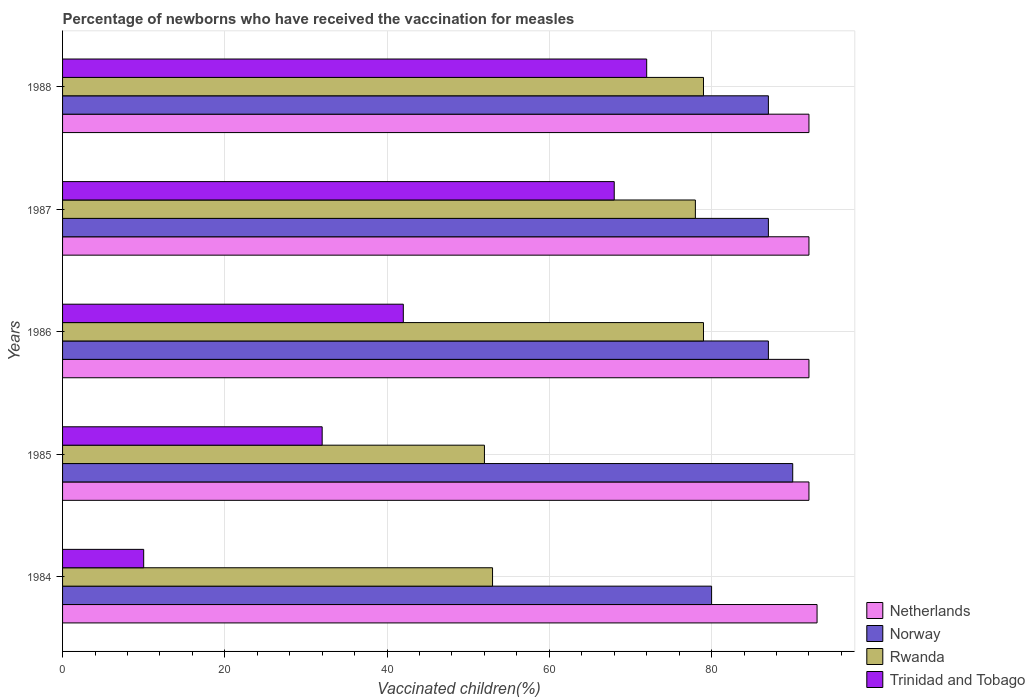Are the number of bars per tick equal to the number of legend labels?
Provide a succinct answer. Yes. Are the number of bars on each tick of the Y-axis equal?
Your response must be concise. Yes. How many bars are there on the 4th tick from the bottom?
Keep it short and to the point. 4. What is the label of the 3rd group of bars from the top?
Ensure brevity in your answer.  1986. What is the percentage of vaccinated children in Netherlands in 1984?
Ensure brevity in your answer.  93. Across all years, what is the maximum percentage of vaccinated children in Trinidad and Tobago?
Ensure brevity in your answer.  72. What is the total percentage of vaccinated children in Rwanda in the graph?
Ensure brevity in your answer.  341. What is the difference between the percentage of vaccinated children in Netherlands in 1987 and the percentage of vaccinated children in Trinidad and Tobago in 1984?
Keep it short and to the point. 82. What is the average percentage of vaccinated children in Rwanda per year?
Offer a terse response. 68.2. In the year 1986, what is the difference between the percentage of vaccinated children in Trinidad and Tobago and percentage of vaccinated children in Netherlands?
Provide a succinct answer. -50. In how many years, is the percentage of vaccinated children in Trinidad and Tobago greater than 72 %?
Your answer should be compact. 0. What is the ratio of the percentage of vaccinated children in Trinidad and Tobago in 1985 to that in 1987?
Make the answer very short. 0.47. Is the percentage of vaccinated children in Norway in 1986 less than that in 1987?
Provide a short and direct response. No. What is the difference between the highest and the second highest percentage of vaccinated children in Netherlands?
Offer a very short reply. 1. What is the difference between the highest and the lowest percentage of vaccinated children in Netherlands?
Your response must be concise. 1. Is the sum of the percentage of vaccinated children in Norway in 1984 and 1986 greater than the maximum percentage of vaccinated children in Rwanda across all years?
Keep it short and to the point. Yes. What does the 4th bar from the bottom in 1986 represents?
Provide a succinct answer. Trinidad and Tobago. Is it the case that in every year, the sum of the percentage of vaccinated children in Norway and percentage of vaccinated children in Rwanda is greater than the percentage of vaccinated children in Trinidad and Tobago?
Ensure brevity in your answer.  Yes. What is the difference between two consecutive major ticks on the X-axis?
Provide a short and direct response. 20. Are the values on the major ticks of X-axis written in scientific E-notation?
Offer a very short reply. No. Does the graph contain grids?
Provide a succinct answer. Yes. Where does the legend appear in the graph?
Provide a short and direct response. Bottom right. How many legend labels are there?
Offer a very short reply. 4. What is the title of the graph?
Make the answer very short. Percentage of newborns who have received the vaccination for measles. What is the label or title of the X-axis?
Provide a succinct answer. Vaccinated children(%). What is the label or title of the Y-axis?
Your answer should be compact. Years. What is the Vaccinated children(%) of Netherlands in 1984?
Give a very brief answer. 93. What is the Vaccinated children(%) of Rwanda in 1984?
Give a very brief answer. 53. What is the Vaccinated children(%) in Trinidad and Tobago in 1984?
Offer a very short reply. 10. What is the Vaccinated children(%) in Netherlands in 1985?
Your answer should be very brief. 92. What is the Vaccinated children(%) of Norway in 1985?
Offer a very short reply. 90. What is the Vaccinated children(%) of Netherlands in 1986?
Keep it short and to the point. 92. What is the Vaccinated children(%) in Norway in 1986?
Offer a very short reply. 87. What is the Vaccinated children(%) in Rwanda in 1986?
Keep it short and to the point. 79. What is the Vaccinated children(%) of Trinidad and Tobago in 1986?
Offer a terse response. 42. What is the Vaccinated children(%) in Netherlands in 1987?
Provide a short and direct response. 92. What is the Vaccinated children(%) in Norway in 1987?
Ensure brevity in your answer.  87. What is the Vaccinated children(%) in Netherlands in 1988?
Keep it short and to the point. 92. What is the Vaccinated children(%) of Norway in 1988?
Your answer should be compact. 87. What is the Vaccinated children(%) of Rwanda in 1988?
Offer a terse response. 79. What is the Vaccinated children(%) in Trinidad and Tobago in 1988?
Offer a very short reply. 72. Across all years, what is the maximum Vaccinated children(%) of Netherlands?
Ensure brevity in your answer.  93. Across all years, what is the maximum Vaccinated children(%) of Rwanda?
Ensure brevity in your answer.  79. Across all years, what is the maximum Vaccinated children(%) in Trinidad and Tobago?
Give a very brief answer. 72. Across all years, what is the minimum Vaccinated children(%) in Netherlands?
Provide a short and direct response. 92. Across all years, what is the minimum Vaccinated children(%) in Norway?
Provide a short and direct response. 80. Across all years, what is the minimum Vaccinated children(%) in Rwanda?
Make the answer very short. 52. Across all years, what is the minimum Vaccinated children(%) in Trinidad and Tobago?
Your response must be concise. 10. What is the total Vaccinated children(%) of Netherlands in the graph?
Make the answer very short. 461. What is the total Vaccinated children(%) of Norway in the graph?
Make the answer very short. 431. What is the total Vaccinated children(%) of Rwanda in the graph?
Your answer should be very brief. 341. What is the total Vaccinated children(%) of Trinidad and Tobago in the graph?
Make the answer very short. 224. What is the difference between the Vaccinated children(%) in Norway in 1984 and that in 1985?
Make the answer very short. -10. What is the difference between the Vaccinated children(%) in Rwanda in 1984 and that in 1985?
Your response must be concise. 1. What is the difference between the Vaccinated children(%) of Trinidad and Tobago in 1984 and that in 1985?
Your answer should be very brief. -22. What is the difference between the Vaccinated children(%) in Rwanda in 1984 and that in 1986?
Offer a terse response. -26. What is the difference between the Vaccinated children(%) of Trinidad and Tobago in 1984 and that in 1986?
Keep it short and to the point. -32. What is the difference between the Vaccinated children(%) in Rwanda in 1984 and that in 1987?
Your answer should be compact. -25. What is the difference between the Vaccinated children(%) in Trinidad and Tobago in 1984 and that in 1987?
Make the answer very short. -58. What is the difference between the Vaccinated children(%) of Rwanda in 1984 and that in 1988?
Your answer should be very brief. -26. What is the difference between the Vaccinated children(%) of Trinidad and Tobago in 1984 and that in 1988?
Your response must be concise. -62. What is the difference between the Vaccinated children(%) in Trinidad and Tobago in 1985 and that in 1987?
Keep it short and to the point. -36. What is the difference between the Vaccinated children(%) in Trinidad and Tobago in 1985 and that in 1988?
Your response must be concise. -40. What is the difference between the Vaccinated children(%) in Rwanda in 1986 and that in 1987?
Provide a succinct answer. 1. What is the difference between the Vaccinated children(%) of Netherlands in 1986 and that in 1988?
Give a very brief answer. 0. What is the difference between the Vaccinated children(%) of Norway in 1986 and that in 1988?
Make the answer very short. 0. What is the difference between the Vaccinated children(%) of Rwanda in 1986 and that in 1988?
Offer a terse response. 0. What is the difference between the Vaccinated children(%) in Trinidad and Tobago in 1986 and that in 1988?
Your answer should be very brief. -30. What is the difference between the Vaccinated children(%) in Netherlands in 1987 and that in 1988?
Give a very brief answer. 0. What is the difference between the Vaccinated children(%) in Norway in 1987 and that in 1988?
Provide a short and direct response. 0. What is the difference between the Vaccinated children(%) of Rwanda in 1987 and that in 1988?
Your answer should be very brief. -1. What is the difference between the Vaccinated children(%) of Trinidad and Tobago in 1987 and that in 1988?
Your response must be concise. -4. What is the difference between the Vaccinated children(%) of Norway in 1984 and the Vaccinated children(%) of Rwanda in 1985?
Offer a terse response. 28. What is the difference between the Vaccinated children(%) in Netherlands in 1984 and the Vaccinated children(%) in Rwanda in 1986?
Provide a short and direct response. 14. What is the difference between the Vaccinated children(%) in Norway in 1984 and the Vaccinated children(%) in Trinidad and Tobago in 1986?
Offer a terse response. 38. What is the difference between the Vaccinated children(%) of Rwanda in 1984 and the Vaccinated children(%) of Trinidad and Tobago in 1986?
Keep it short and to the point. 11. What is the difference between the Vaccinated children(%) of Netherlands in 1984 and the Vaccinated children(%) of Norway in 1987?
Provide a succinct answer. 6. What is the difference between the Vaccinated children(%) in Netherlands in 1984 and the Vaccinated children(%) in Rwanda in 1987?
Give a very brief answer. 15. What is the difference between the Vaccinated children(%) of Rwanda in 1984 and the Vaccinated children(%) of Trinidad and Tobago in 1987?
Give a very brief answer. -15. What is the difference between the Vaccinated children(%) of Norway in 1984 and the Vaccinated children(%) of Rwanda in 1988?
Provide a succinct answer. 1. What is the difference between the Vaccinated children(%) in Rwanda in 1984 and the Vaccinated children(%) in Trinidad and Tobago in 1988?
Your response must be concise. -19. What is the difference between the Vaccinated children(%) in Netherlands in 1985 and the Vaccinated children(%) in Trinidad and Tobago in 1986?
Offer a very short reply. 50. What is the difference between the Vaccinated children(%) in Norway in 1985 and the Vaccinated children(%) in Rwanda in 1986?
Give a very brief answer. 11. What is the difference between the Vaccinated children(%) of Norway in 1985 and the Vaccinated children(%) of Trinidad and Tobago in 1986?
Your response must be concise. 48. What is the difference between the Vaccinated children(%) of Rwanda in 1985 and the Vaccinated children(%) of Trinidad and Tobago in 1986?
Provide a short and direct response. 10. What is the difference between the Vaccinated children(%) of Netherlands in 1985 and the Vaccinated children(%) of Norway in 1987?
Your response must be concise. 5. What is the difference between the Vaccinated children(%) of Netherlands in 1985 and the Vaccinated children(%) of Trinidad and Tobago in 1987?
Provide a short and direct response. 24. What is the difference between the Vaccinated children(%) in Norway in 1985 and the Vaccinated children(%) in Trinidad and Tobago in 1987?
Keep it short and to the point. 22. What is the difference between the Vaccinated children(%) in Netherlands in 1985 and the Vaccinated children(%) in Norway in 1988?
Provide a succinct answer. 5. What is the difference between the Vaccinated children(%) in Netherlands in 1985 and the Vaccinated children(%) in Rwanda in 1988?
Offer a very short reply. 13. What is the difference between the Vaccinated children(%) in Norway in 1985 and the Vaccinated children(%) in Rwanda in 1988?
Give a very brief answer. 11. What is the difference between the Vaccinated children(%) of Norway in 1985 and the Vaccinated children(%) of Trinidad and Tobago in 1988?
Ensure brevity in your answer.  18. What is the difference between the Vaccinated children(%) of Norway in 1986 and the Vaccinated children(%) of Trinidad and Tobago in 1987?
Keep it short and to the point. 19. What is the difference between the Vaccinated children(%) in Netherlands in 1986 and the Vaccinated children(%) in Norway in 1988?
Provide a short and direct response. 5. What is the difference between the Vaccinated children(%) of Netherlands in 1986 and the Vaccinated children(%) of Rwanda in 1988?
Ensure brevity in your answer.  13. What is the difference between the Vaccinated children(%) of Norway in 1986 and the Vaccinated children(%) of Rwanda in 1988?
Your answer should be compact. 8. What is the difference between the Vaccinated children(%) in Rwanda in 1986 and the Vaccinated children(%) in Trinidad and Tobago in 1988?
Ensure brevity in your answer.  7. What is the difference between the Vaccinated children(%) of Netherlands in 1987 and the Vaccinated children(%) of Trinidad and Tobago in 1988?
Give a very brief answer. 20. What is the difference between the Vaccinated children(%) in Norway in 1987 and the Vaccinated children(%) in Rwanda in 1988?
Provide a succinct answer. 8. What is the average Vaccinated children(%) in Netherlands per year?
Your response must be concise. 92.2. What is the average Vaccinated children(%) in Norway per year?
Provide a short and direct response. 86.2. What is the average Vaccinated children(%) in Rwanda per year?
Offer a very short reply. 68.2. What is the average Vaccinated children(%) of Trinidad and Tobago per year?
Ensure brevity in your answer.  44.8. In the year 1984, what is the difference between the Vaccinated children(%) in Netherlands and Vaccinated children(%) in Norway?
Your answer should be compact. 13. In the year 1984, what is the difference between the Vaccinated children(%) of Netherlands and Vaccinated children(%) of Rwanda?
Provide a succinct answer. 40. In the year 1984, what is the difference between the Vaccinated children(%) in Norway and Vaccinated children(%) in Rwanda?
Give a very brief answer. 27. In the year 1984, what is the difference between the Vaccinated children(%) of Norway and Vaccinated children(%) of Trinidad and Tobago?
Provide a succinct answer. 70. In the year 1984, what is the difference between the Vaccinated children(%) in Rwanda and Vaccinated children(%) in Trinidad and Tobago?
Ensure brevity in your answer.  43. In the year 1985, what is the difference between the Vaccinated children(%) of Netherlands and Vaccinated children(%) of Norway?
Offer a terse response. 2. In the year 1985, what is the difference between the Vaccinated children(%) of Netherlands and Vaccinated children(%) of Trinidad and Tobago?
Your answer should be very brief. 60. In the year 1985, what is the difference between the Vaccinated children(%) of Norway and Vaccinated children(%) of Rwanda?
Your response must be concise. 38. In the year 1985, what is the difference between the Vaccinated children(%) in Rwanda and Vaccinated children(%) in Trinidad and Tobago?
Ensure brevity in your answer.  20. In the year 1986, what is the difference between the Vaccinated children(%) in Netherlands and Vaccinated children(%) in Norway?
Provide a succinct answer. 5. In the year 1986, what is the difference between the Vaccinated children(%) in Netherlands and Vaccinated children(%) in Rwanda?
Ensure brevity in your answer.  13. In the year 1986, what is the difference between the Vaccinated children(%) in Norway and Vaccinated children(%) in Trinidad and Tobago?
Make the answer very short. 45. In the year 1987, what is the difference between the Vaccinated children(%) in Netherlands and Vaccinated children(%) in Rwanda?
Your answer should be compact. 14. In the year 1987, what is the difference between the Vaccinated children(%) of Netherlands and Vaccinated children(%) of Trinidad and Tobago?
Your answer should be compact. 24. In the year 1987, what is the difference between the Vaccinated children(%) of Norway and Vaccinated children(%) of Rwanda?
Your answer should be compact. 9. In the year 1987, what is the difference between the Vaccinated children(%) in Rwanda and Vaccinated children(%) in Trinidad and Tobago?
Your answer should be compact. 10. In the year 1988, what is the difference between the Vaccinated children(%) of Netherlands and Vaccinated children(%) of Norway?
Provide a succinct answer. 5. In the year 1988, what is the difference between the Vaccinated children(%) of Norway and Vaccinated children(%) of Rwanda?
Provide a succinct answer. 8. In the year 1988, what is the difference between the Vaccinated children(%) of Norway and Vaccinated children(%) of Trinidad and Tobago?
Your answer should be very brief. 15. In the year 1988, what is the difference between the Vaccinated children(%) of Rwanda and Vaccinated children(%) of Trinidad and Tobago?
Keep it short and to the point. 7. What is the ratio of the Vaccinated children(%) in Netherlands in 1984 to that in 1985?
Keep it short and to the point. 1.01. What is the ratio of the Vaccinated children(%) of Norway in 1984 to that in 1985?
Your answer should be compact. 0.89. What is the ratio of the Vaccinated children(%) of Rwanda in 1984 to that in 1985?
Your answer should be very brief. 1.02. What is the ratio of the Vaccinated children(%) in Trinidad and Tobago in 1984 to that in 1985?
Give a very brief answer. 0.31. What is the ratio of the Vaccinated children(%) of Netherlands in 1984 to that in 1986?
Provide a succinct answer. 1.01. What is the ratio of the Vaccinated children(%) of Norway in 1984 to that in 1986?
Your answer should be very brief. 0.92. What is the ratio of the Vaccinated children(%) in Rwanda in 1984 to that in 1986?
Offer a terse response. 0.67. What is the ratio of the Vaccinated children(%) in Trinidad and Tobago in 1984 to that in 1986?
Your answer should be compact. 0.24. What is the ratio of the Vaccinated children(%) of Netherlands in 1984 to that in 1987?
Keep it short and to the point. 1.01. What is the ratio of the Vaccinated children(%) in Norway in 1984 to that in 1987?
Provide a short and direct response. 0.92. What is the ratio of the Vaccinated children(%) in Rwanda in 1984 to that in 1987?
Keep it short and to the point. 0.68. What is the ratio of the Vaccinated children(%) of Trinidad and Tobago in 1984 to that in 1987?
Provide a succinct answer. 0.15. What is the ratio of the Vaccinated children(%) in Netherlands in 1984 to that in 1988?
Offer a terse response. 1.01. What is the ratio of the Vaccinated children(%) in Norway in 1984 to that in 1988?
Make the answer very short. 0.92. What is the ratio of the Vaccinated children(%) of Rwanda in 1984 to that in 1988?
Offer a terse response. 0.67. What is the ratio of the Vaccinated children(%) of Trinidad and Tobago in 1984 to that in 1988?
Your answer should be very brief. 0.14. What is the ratio of the Vaccinated children(%) of Netherlands in 1985 to that in 1986?
Make the answer very short. 1. What is the ratio of the Vaccinated children(%) in Norway in 1985 to that in 1986?
Provide a short and direct response. 1.03. What is the ratio of the Vaccinated children(%) in Rwanda in 1985 to that in 1986?
Keep it short and to the point. 0.66. What is the ratio of the Vaccinated children(%) in Trinidad and Tobago in 1985 to that in 1986?
Offer a very short reply. 0.76. What is the ratio of the Vaccinated children(%) in Netherlands in 1985 to that in 1987?
Provide a short and direct response. 1. What is the ratio of the Vaccinated children(%) of Norway in 1985 to that in 1987?
Ensure brevity in your answer.  1.03. What is the ratio of the Vaccinated children(%) of Rwanda in 1985 to that in 1987?
Keep it short and to the point. 0.67. What is the ratio of the Vaccinated children(%) of Trinidad and Tobago in 1985 to that in 1987?
Ensure brevity in your answer.  0.47. What is the ratio of the Vaccinated children(%) of Netherlands in 1985 to that in 1988?
Provide a short and direct response. 1. What is the ratio of the Vaccinated children(%) of Norway in 1985 to that in 1988?
Offer a terse response. 1.03. What is the ratio of the Vaccinated children(%) of Rwanda in 1985 to that in 1988?
Your answer should be very brief. 0.66. What is the ratio of the Vaccinated children(%) in Trinidad and Tobago in 1985 to that in 1988?
Provide a short and direct response. 0.44. What is the ratio of the Vaccinated children(%) of Netherlands in 1986 to that in 1987?
Your answer should be compact. 1. What is the ratio of the Vaccinated children(%) of Norway in 1986 to that in 1987?
Your response must be concise. 1. What is the ratio of the Vaccinated children(%) of Rwanda in 1986 to that in 1987?
Make the answer very short. 1.01. What is the ratio of the Vaccinated children(%) of Trinidad and Tobago in 1986 to that in 1987?
Make the answer very short. 0.62. What is the ratio of the Vaccinated children(%) of Norway in 1986 to that in 1988?
Your response must be concise. 1. What is the ratio of the Vaccinated children(%) in Trinidad and Tobago in 1986 to that in 1988?
Give a very brief answer. 0.58. What is the ratio of the Vaccinated children(%) in Netherlands in 1987 to that in 1988?
Offer a terse response. 1. What is the ratio of the Vaccinated children(%) in Norway in 1987 to that in 1988?
Make the answer very short. 1. What is the ratio of the Vaccinated children(%) in Rwanda in 1987 to that in 1988?
Give a very brief answer. 0.99. What is the difference between the highest and the second highest Vaccinated children(%) in Netherlands?
Offer a very short reply. 1. What is the difference between the highest and the second highest Vaccinated children(%) in Norway?
Provide a succinct answer. 3. What is the difference between the highest and the lowest Vaccinated children(%) of Rwanda?
Ensure brevity in your answer.  27. What is the difference between the highest and the lowest Vaccinated children(%) in Trinidad and Tobago?
Keep it short and to the point. 62. 